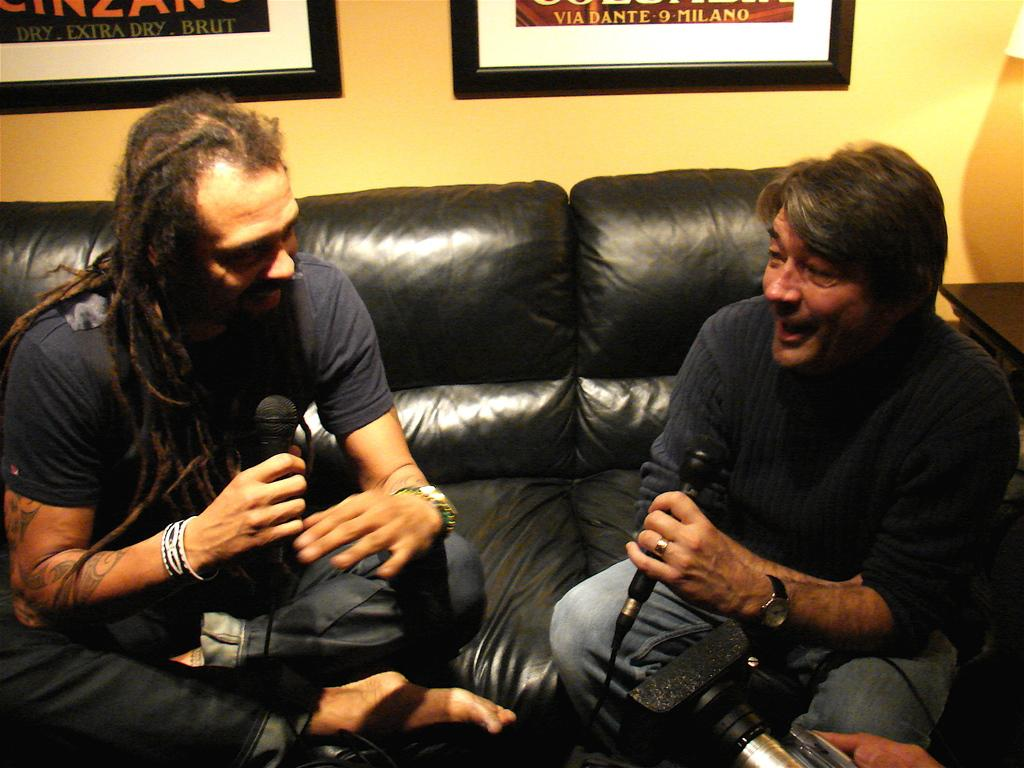How many people are sitting in the image? There are two persons sitting in the image. What are the persons sitting on? The persons are sitting on a sofa. What expression do the persons have? The persons are smiling. What is the man holding in the image? The man is holding a microphone in the image. What can be seen on the wall in the image? There is a photo frame on the wall. What type of leaf can be seen falling from the ceiling in the image? There is no leaf falling from the ceiling in the image. What toys are the persons playing with in the image? There are no toys present in the image; the persons are sitting on a sofa and smiling. 